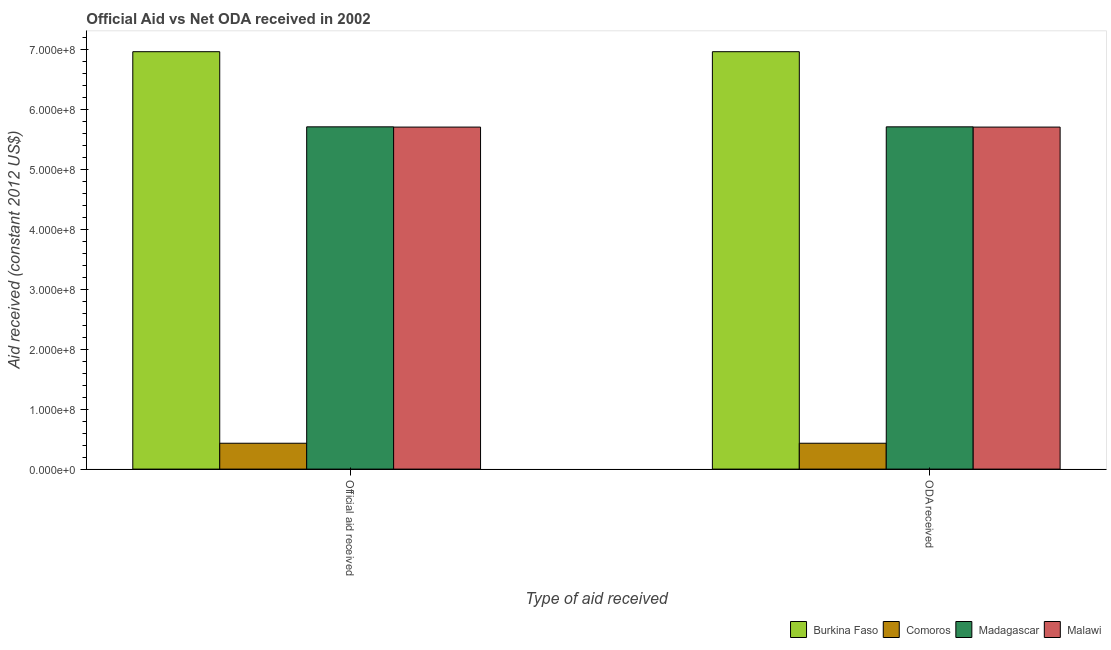Are the number of bars on each tick of the X-axis equal?
Give a very brief answer. Yes. How many bars are there on the 2nd tick from the right?
Offer a very short reply. 4. What is the label of the 2nd group of bars from the left?
Keep it short and to the point. ODA received. What is the official aid received in Burkina Faso?
Your response must be concise. 6.97e+08. Across all countries, what is the maximum official aid received?
Ensure brevity in your answer.  6.97e+08. Across all countries, what is the minimum oda received?
Keep it short and to the point. 4.32e+07. In which country was the official aid received maximum?
Provide a succinct answer. Burkina Faso. In which country was the oda received minimum?
Make the answer very short. Comoros. What is the total official aid received in the graph?
Your answer should be compact. 1.88e+09. What is the difference between the official aid received in Madagascar and that in Burkina Faso?
Provide a short and direct response. -1.25e+08. What is the difference between the oda received in Madagascar and the official aid received in Burkina Faso?
Give a very brief answer. -1.25e+08. What is the average oda received per country?
Make the answer very short. 4.71e+08. What is the ratio of the oda received in Madagascar to that in Burkina Faso?
Your response must be concise. 0.82. In how many countries, is the oda received greater than the average oda received taken over all countries?
Offer a very short reply. 3. What does the 3rd bar from the left in ODA received represents?
Your answer should be compact. Madagascar. What does the 4th bar from the right in ODA received represents?
Give a very brief answer. Burkina Faso. How many bars are there?
Offer a terse response. 8. Are all the bars in the graph horizontal?
Provide a succinct answer. No. Are the values on the major ticks of Y-axis written in scientific E-notation?
Offer a very short reply. Yes. Does the graph contain any zero values?
Keep it short and to the point. No. Where does the legend appear in the graph?
Your response must be concise. Bottom right. What is the title of the graph?
Your response must be concise. Official Aid vs Net ODA received in 2002 . Does "Tunisia" appear as one of the legend labels in the graph?
Give a very brief answer. No. What is the label or title of the X-axis?
Your answer should be very brief. Type of aid received. What is the label or title of the Y-axis?
Ensure brevity in your answer.  Aid received (constant 2012 US$). What is the Aid received (constant 2012 US$) in Burkina Faso in Official aid received?
Keep it short and to the point. 6.97e+08. What is the Aid received (constant 2012 US$) of Comoros in Official aid received?
Make the answer very short. 4.32e+07. What is the Aid received (constant 2012 US$) of Madagascar in Official aid received?
Your answer should be very brief. 5.72e+08. What is the Aid received (constant 2012 US$) in Malawi in Official aid received?
Offer a very short reply. 5.71e+08. What is the Aid received (constant 2012 US$) in Burkina Faso in ODA received?
Provide a succinct answer. 6.97e+08. What is the Aid received (constant 2012 US$) of Comoros in ODA received?
Offer a very short reply. 4.32e+07. What is the Aid received (constant 2012 US$) in Madagascar in ODA received?
Make the answer very short. 5.72e+08. What is the Aid received (constant 2012 US$) of Malawi in ODA received?
Give a very brief answer. 5.71e+08. Across all Type of aid received, what is the maximum Aid received (constant 2012 US$) in Burkina Faso?
Offer a very short reply. 6.97e+08. Across all Type of aid received, what is the maximum Aid received (constant 2012 US$) of Comoros?
Provide a succinct answer. 4.32e+07. Across all Type of aid received, what is the maximum Aid received (constant 2012 US$) of Madagascar?
Your answer should be very brief. 5.72e+08. Across all Type of aid received, what is the maximum Aid received (constant 2012 US$) in Malawi?
Your answer should be very brief. 5.71e+08. Across all Type of aid received, what is the minimum Aid received (constant 2012 US$) in Burkina Faso?
Give a very brief answer. 6.97e+08. Across all Type of aid received, what is the minimum Aid received (constant 2012 US$) of Comoros?
Offer a terse response. 4.32e+07. Across all Type of aid received, what is the minimum Aid received (constant 2012 US$) in Madagascar?
Give a very brief answer. 5.72e+08. Across all Type of aid received, what is the minimum Aid received (constant 2012 US$) in Malawi?
Your answer should be compact. 5.71e+08. What is the total Aid received (constant 2012 US$) in Burkina Faso in the graph?
Make the answer very short. 1.39e+09. What is the total Aid received (constant 2012 US$) in Comoros in the graph?
Your answer should be very brief. 8.64e+07. What is the total Aid received (constant 2012 US$) of Madagascar in the graph?
Provide a short and direct response. 1.14e+09. What is the total Aid received (constant 2012 US$) in Malawi in the graph?
Provide a short and direct response. 1.14e+09. What is the difference between the Aid received (constant 2012 US$) in Madagascar in Official aid received and that in ODA received?
Give a very brief answer. 0. What is the difference between the Aid received (constant 2012 US$) in Burkina Faso in Official aid received and the Aid received (constant 2012 US$) in Comoros in ODA received?
Make the answer very short. 6.54e+08. What is the difference between the Aid received (constant 2012 US$) of Burkina Faso in Official aid received and the Aid received (constant 2012 US$) of Madagascar in ODA received?
Offer a very short reply. 1.25e+08. What is the difference between the Aid received (constant 2012 US$) of Burkina Faso in Official aid received and the Aid received (constant 2012 US$) of Malawi in ODA received?
Your response must be concise. 1.26e+08. What is the difference between the Aid received (constant 2012 US$) in Comoros in Official aid received and the Aid received (constant 2012 US$) in Madagascar in ODA received?
Ensure brevity in your answer.  -5.28e+08. What is the difference between the Aid received (constant 2012 US$) in Comoros in Official aid received and the Aid received (constant 2012 US$) in Malawi in ODA received?
Offer a terse response. -5.28e+08. What is the difference between the Aid received (constant 2012 US$) of Madagascar in Official aid received and the Aid received (constant 2012 US$) of Malawi in ODA received?
Offer a very short reply. 4.30e+05. What is the average Aid received (constant 2012 US$) of Burkina Faso per Type of aid received?
Give a very brief answer. 6.97e+08. What is the average Aid received (constant 2012 US$) in Comoros per Type of aid received?
Give a very brief answer. 4.32e+07. What is the average Aid received (constant 2012 US$) in Madagascar per Type of aid received?
Keep it short and to the point. 5.72e+08. What is the average Aid received (constant 2012 US$) of Malawi per Type of aid received?
Make the answer very short. 5.71e+08. What is the difference between the Aid received (constant 2012 US$) in Burkina Faso and Aid received (constant 2012 US$) in Comoros in Official aid received?
Your answer should be very brief. 6.54e+08. What is the difference between the Aid received (constant 2012 US$) of Burkina Faso and Aid received (constant 2012 US$) of Madagascar in Official aid received?
Keep it short and to the point. 1.25e+08. What is the difference between the Aid received (constant 2012 US$) of Burkina Faso and Aid received (constant 2012 US$) of Malawi in Official aid received?
Make the answer very short. 1.26e+08. What is the difference between the Aid received (constant 2012 US$) of Comoros and Aid received (constant 2012 US$) of Madagascar in Official aid received?
Your answer should be very brief. -5.28e+08. What is the difference between the Aid received (constant 2012 US$) in Comoros and Aid received (constant 2012 US$) in Malawi in Official aid received?
Your response must be concise. -5.28e+08. What is the difference between the Aid received (constant 2012 US$) of Burkina Faso and Aid received (constant 2012 US$) of Comoros in ODA received?
Keep it short and to the point. 6.54e+08. What is the difference between the Aid received (constant 2012 US$) in Burkina Faso and Aid received (constant 2012 US$) in Madagascar in ODA received?
Offer a very short reply. 1.25e+08. What is the difference between the Aid received (constant 2012 US$) of Burkina Faso and Aid received (constant 2012 US$) of Malawi in ODA received?
Your answer should be compact. 1.26e+08. What is the difference between the Aid received (constant 2012 US$) in Comoros and Aid received (constant 2012 US$) in Madagascar in ODA received?
Your answer should be compact. -5.28e+08. What is the difference between the Aid received (constant 2012 US$) of Comoros and Aid received (constant 2012 US$) of Malawi in ODA received?
Offer a terse response. -5.28e+08. What is the ratio of the Aid received (constant 2012 US$) in Burkina Faso in Official aid received to that in ODA received?
Provide a short and direct response. 1. What is the ratio of the Aid received (constant 2012 US$) in Malawi in Official aid received to that in ODA received?
Keep it short and to the point. 1. What is the difference between the highest and the second highest Aid received (constant 2012 US$) of Burkina Faso?
Your answer should be very brief. 0. What is the difference between the highest and the second highest Aid received (constant 2012 US$) of Comoros?
Your response must be concise. 0. What is the difference between the highest and the second highest Aid received (constant 2012 US$) of Malawi?
Your answer should be compact. 0. 